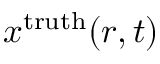Convert formula to latex. <formula><loc_0><loc_0><loc_500><loc_500>x ^ { t r u t h } ( r , t )</formula> 